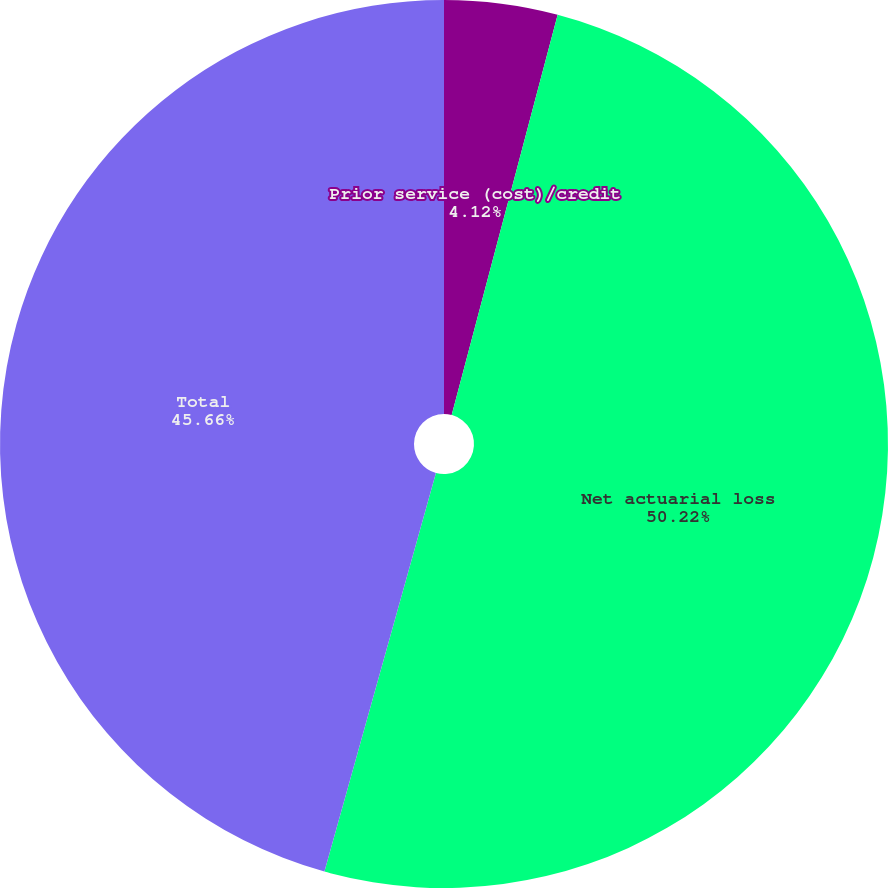Convert chart. <chart><loc_0><loc_0><loc_500><loc_500><pie_chart><fcel>Prior service (cost)/credit<fcel>Net actuarial loss<fcel>Total<nl><fcel>4.12%<fcel>50.22%<fcel>45.66%<nl></chart> 